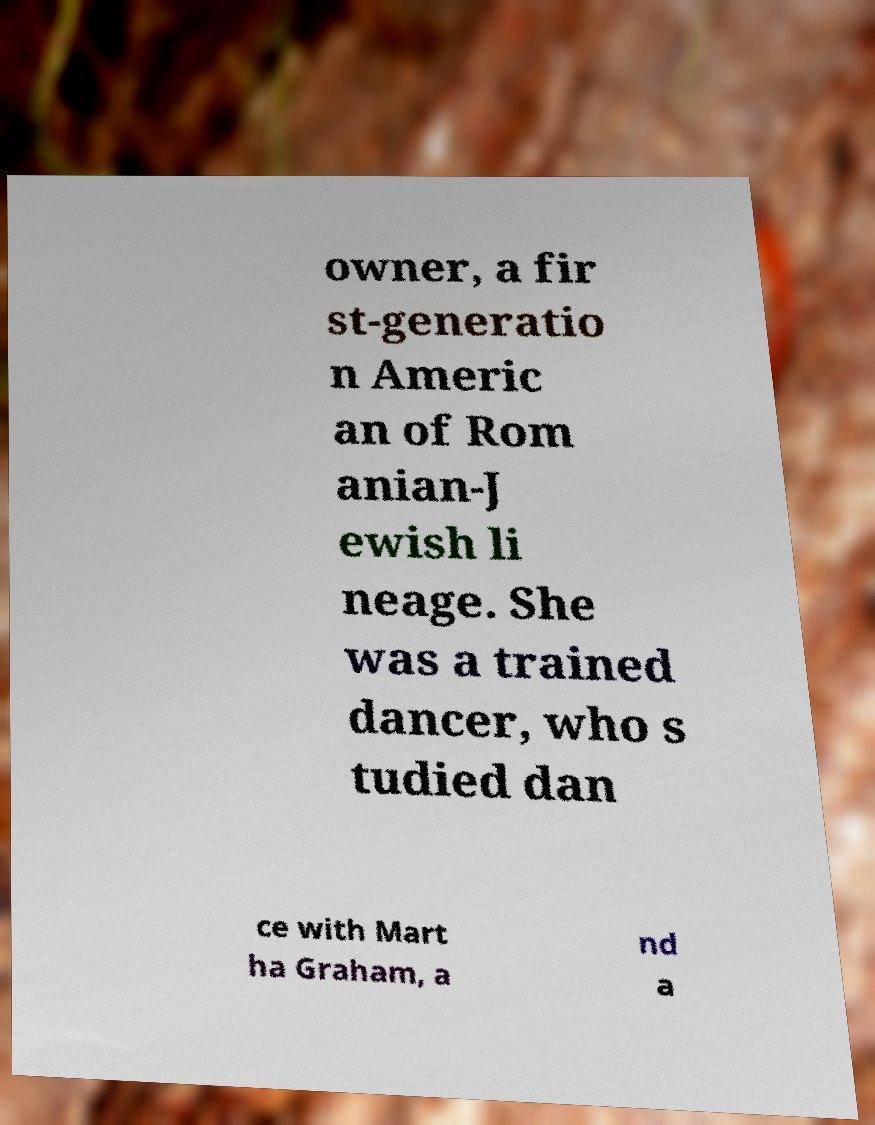Can you accurately transcribe the text from the provided image for me? owner, a fir st-generatio n Americ an of Rom anian-J ewish li neage. She was a trained dancer, who s tudied dan ce with Mart ha Graham, a nd a 